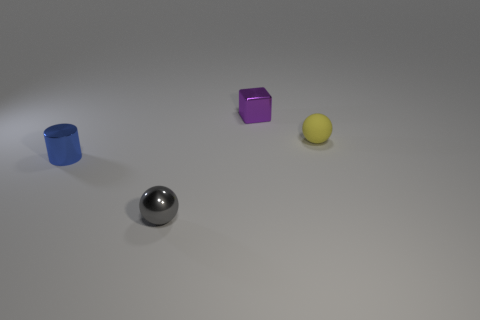What color is the ball on the right side of the tiny purple metallic object?
Give a very brief answer. Yellow. There is another tiny thing that is the same shape as the small gray metallic object; what is its color?
Offer a very short reply. Yellow. There is a shiny thing behind the ball behind the gray object; what number of matte balls are left of it?
Your response must be concise. 0. Is there any other thing that has the same material as the small yellow object?
Keep it short and to the point. No. Is the number of small metal balls right of the purple thing less than the number of tiny cyan cylinders?
Provide a succinct answer. No. How many things have the same material as the purple block?
Offer a very short reply. 2. Do the ball right of the small metallic block and the tiny gray ball have the same material?
Your answer should be very brief. No. Are there the same number of tiny shiny balls behind the tiny purple block and blue cylinders?
Your answer should be compact. No. How big is the gray metal ball?
Make the answer very short. Small. How many spheres are the same color as the tiny rubber thing?
Offer a very short reply. 0. 